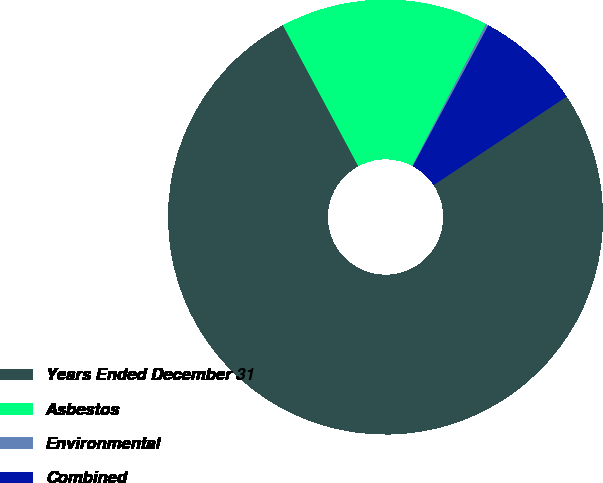Convert chart to OTSL. <chart><loc_0><loc_0><loc_500><loc_500><pie_chart><fcel>Years Ended December 31<fcel>Asbestos<fcel>Environmental<fcel>Combined<nl><fcel>76.53%<fcel>15.46%<fcel>0.19%<fcel>7.82%<nl></chart> 